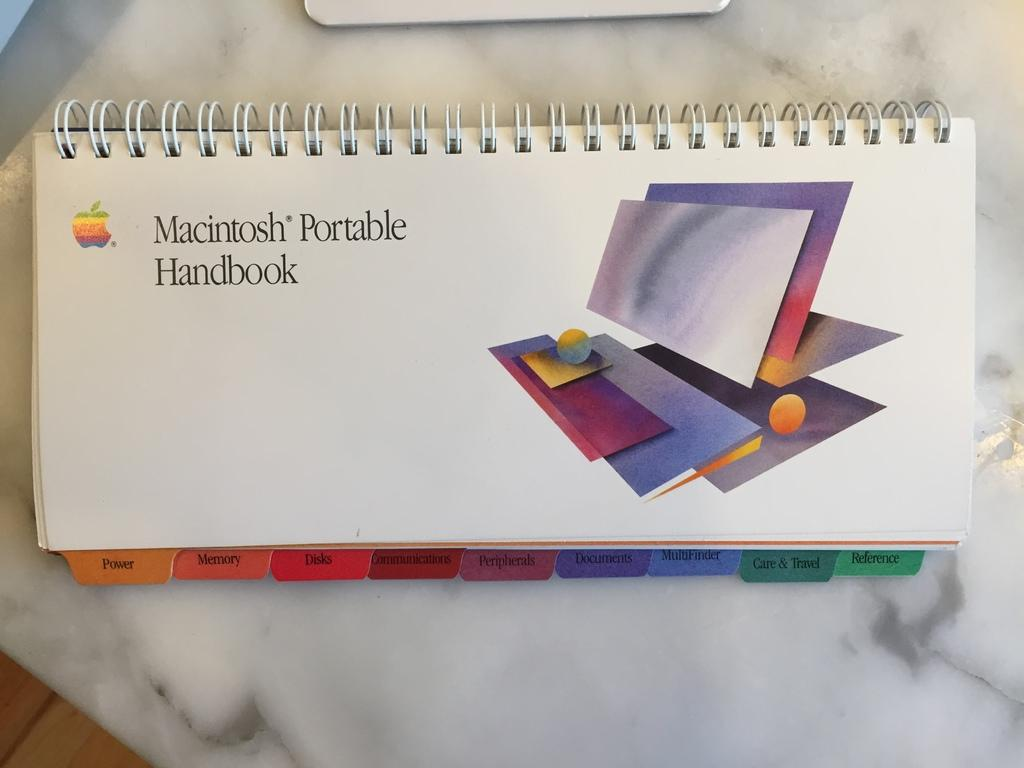<image>
Summarize the visual content of the image. A spiral book with many tabs on it that is called Macintosh Portable Handbook laying on a table. 